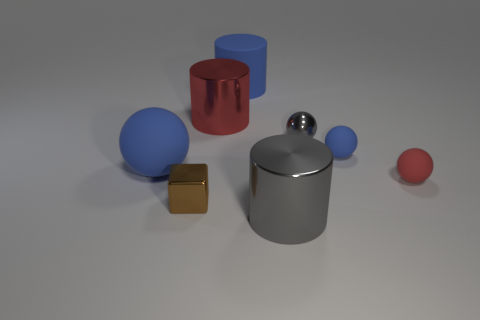Subtract all shiny cylinders. How many cylinders are left? 1 Add 1 yellow metal objects. How many objects exist? 9 Subtract all yellow spheres. Subtract all red cylinders. How many spheres are left? 4 Subtract all cylinders. How many objects are left? 5 Subtract 0 cyan cylinders. How many objects are left? 8 Subtract all tiny gray metal objects. Subtract all yellow shiny things. How many objects are left? 7 Add 6 rubber balls. How many rubber balls are left? 9 Add 5 small blue metal cylinders. How many small blue metal cylinders exist? 5 